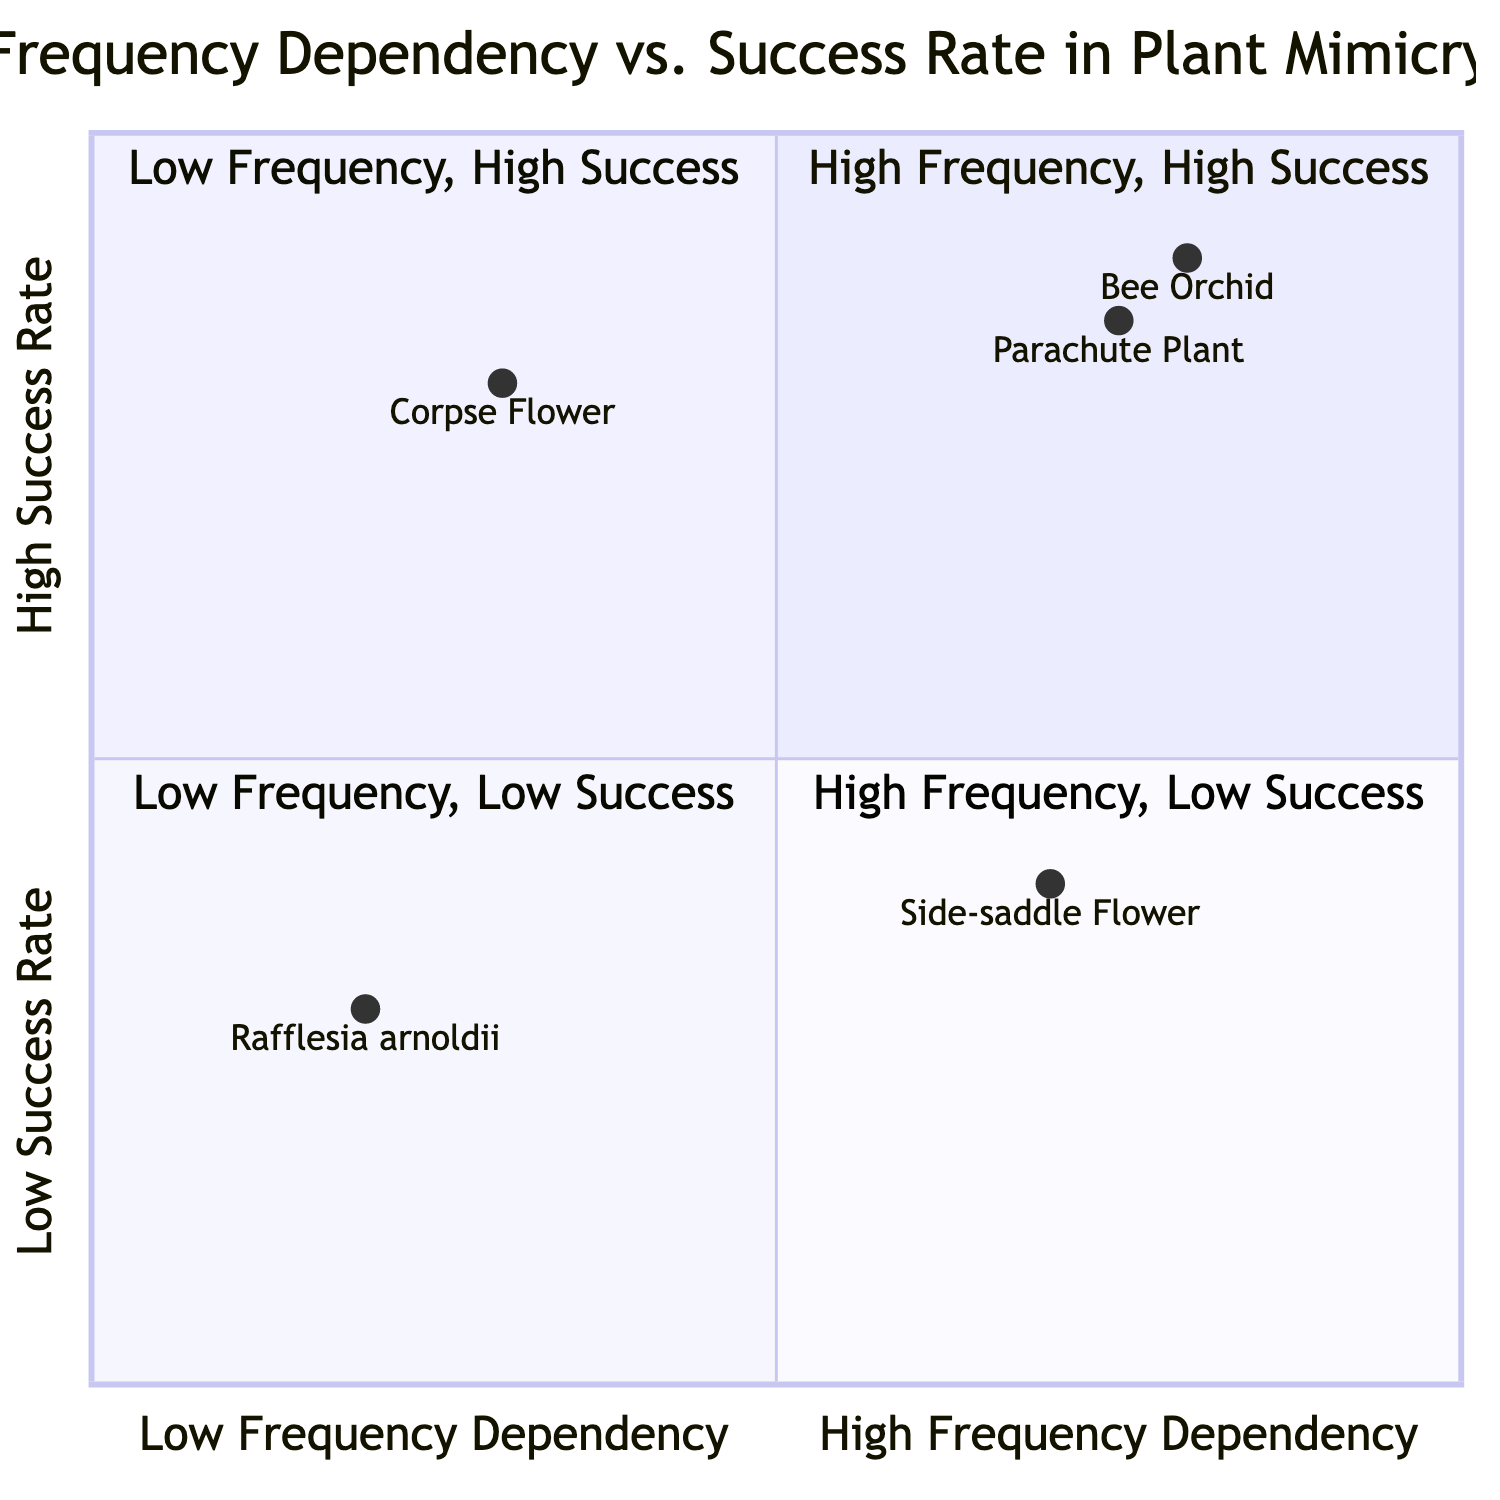What species is found in Quadrant 1? Quadrant 1 contains two species: Bee Orchid and South African Parachute Plant.
Answer: Bee Orchid, South African Parachute Plant What is the success rate of the Corpse Flower? The Corpse Flower is located in Quadrant 2, which indicates it has a high success rate, and its specific success rate is 0.8.
Answer: 0.8 Which quadrant has plants with low frequency dependency and low success rate? Quadrant 3 is described as having low frequency dependency and low success rate, containing only Rafflesia arnoldii.
Answer: Quadrant 3 What is the frequency dependency of the Side-saddle Flower? The Side-saddle Flower's frequency dependency value is found in Quadrant 4, where it is noted as 0.7, indicating high frequency dependency.
Answer: 0.7 How many species are in Quadrant 2? Quadrant 2 contains only one species, the Corpse Flower.
Answer: 1 Which plant exhibits high frequency dependency and low success rate? According to the diagram, the Side-saddle Flower is the example of a plant that exhibits high frequency dependency and has a low success rate.
Answer: Side-saddle Flower What is the frequency dependency range of plants in Quadrant 1? Quadrant 1 shows high frequency dependency, with the range of the species Bee Orchid at 0.8 and the South African Parachute Plant at 0.75, indicating it is in the upper range.
Answer: 0.75 to 0.8 What cues does the South African Parachute Plant use for attraction? The South African Parachute Plant uses a combination of visual and olfactory cues for attracting specific fly species, as indicated in the quadrant description.
Answer: Visual and olfactory cues What does a lower success rate imply about Rafflesia arnoldii? Rafflesia arnoldii has a low success rate, as indicated in Quadrant 3, which implies its pollination success is uncertain and consistent, impacted by infrequent blooming.
Answer: Uncertain pollination success 